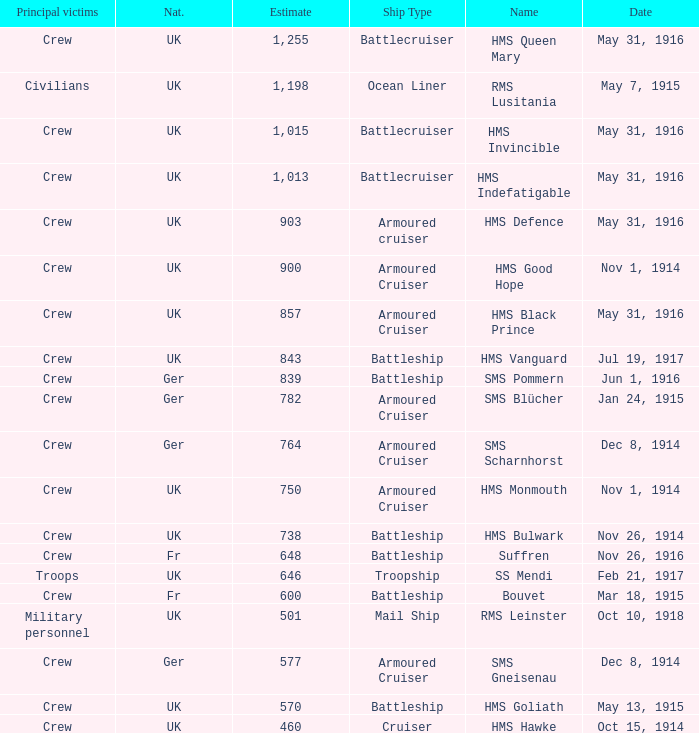What is the nationality of the ship when the principle victims are civilians? UK. 